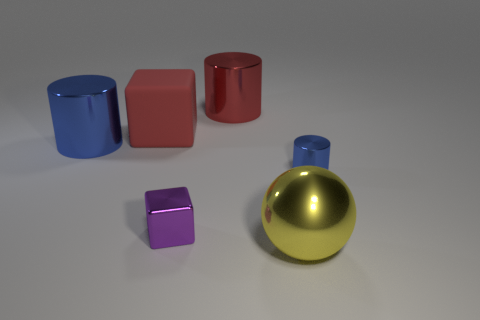Add 3 red cylinders. How many objects exist? 9 Subtract all blocks. How many objects are left? 4 Subtract 0 gray blocks. How many objects are left? 6 Subtract all large red matte things. Subtract all red objects. How many objects are left? 3 Add 6 red metallic cylinders. How many red metallic cylinders are left? 7 Add 1 large cyan objects. How many large cyan objects exist? 1 